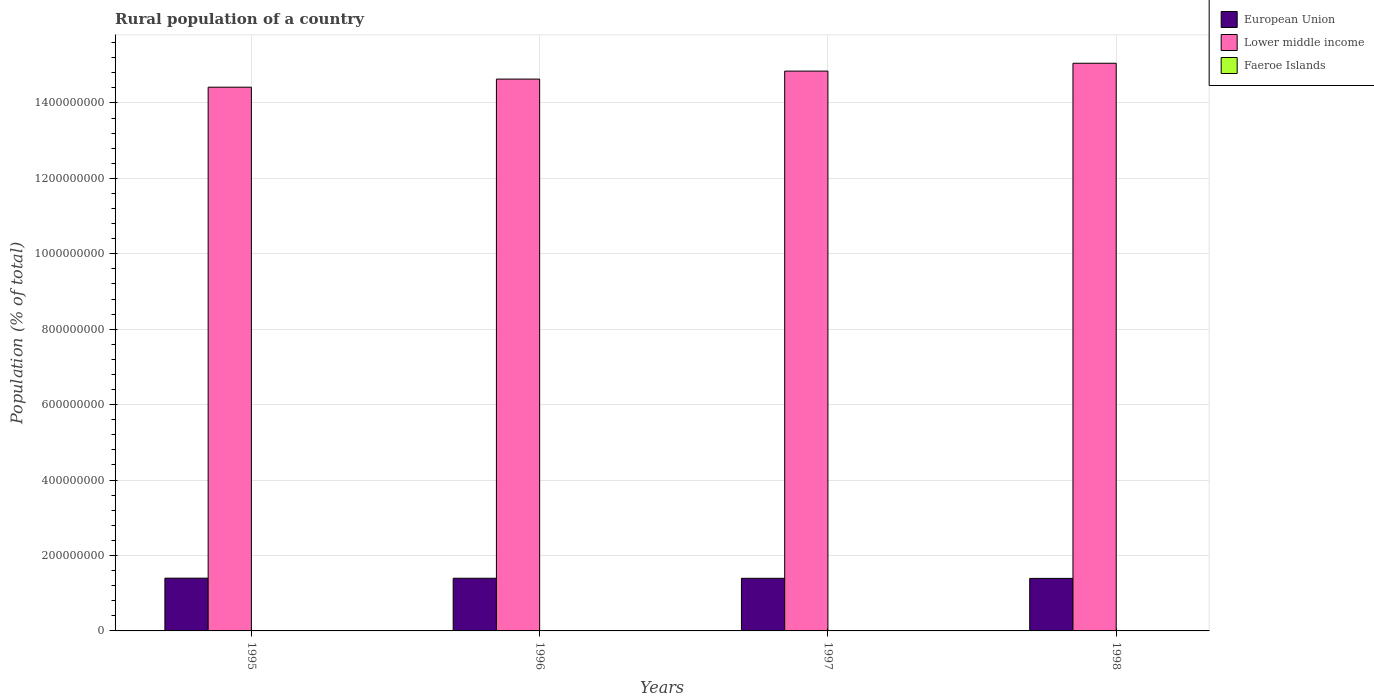How many groups of bars are there?
Make the answer very short. 4. Are the number of bars per tick equal to the number of legend labels?
Ensure brevity in your answer.  Yes. How many bars are there on the 4th tick from the left?
Give a very brief answer. 3. What is the label of the 2nd group of bars from the left?
Ensure brevity in your answer.  1996. What is the rural population in Lower middle income in 1998?
Offer a very short reply. 1.51e+09. Across all years, what is the maximum rural population in European Union?
Offer a terse response. 1.40e+08. Across all years, what is the minimum rural population in Lower middle income?
Your response must be concise. 1.44e+09. What is the total rural population in European Union in the graph?
Your answer should be very brief. 5.58e+08. What is the difference between the rural population in European Union in 1997 and that in 1998?
Ensure brevity in your answer.  2.23e+05. What is the difference between the rural population in European Union in 1997 and the rural population in Faeroe Islands in 1996?
Make the answer very short. 1.39e+08. What is the average rural population in Lower middle income per year?
Make the answer very short. 1.47e+09. In the year 1997, what is the difference between the rural population in Lower middle income and rural population in European Union?
Give a very brief answer. 1.34e+09. What is the ratio of the rural population in Faeroe Islands in 1997 to that in 1998?
Provide a short and direct response. 0.99. Is the rural population in Lower middle income in 1996 less than that in 1997?
Your answer should be compact. Yes. What is the difference between the highest and the second highest rural population in Faeroe Islands?
Provide a short and direct response. 942. What is the difference between the highest and the lowest rural population in Faeroe Islands?
Ensure brevity in your answer.  1715. In how many years, is the rural population in European Union greater than the average rural population in European Union taken over all years?
Your response must be concise. 2. What does the 2nd bar from the left in 1996 represents?
Your answer should be very brief. Lower middle income. What does the 1st bar from the right in 1995 represents?
Make the answer very short. Faeroe Islands. How many bars are there?
Give a very brief answer. 12. Are all the bars in the graph horizontal?
Make the answer very short. No. What is the difference between two consecutive major ticks on the Y-axis?
Ensure brevity in your answer.  2.00e+08. Does the graph contain any zero values?
Provide a succinct answer. No. Does the graph contain grids?
Provide a succinct answer. Yes. How are the legend labels stacked?
Ensure brevity in your answer.  Vertical. What is the title of the graph?
Your response must be concise. Rural population of a country. Does "St. Lucia" appear as one of the legend labels in the graph?
Provide a short and direct response. No. What is the label or title of the Y-axis?
Offer a terse response. Population (% of total). What is the Population (% of total) in European Union in 1995?
Your response must be concise. 1.40e+08. What is the Population (% of total) of Lower middle income in 1995?
Keep it short and to the point. 1.44e+09. What is the Population (% of total) of Faeroe Islands in 1995?
Your answer should be compact. 3.05e+04. What is the Population (% of total) in European Union in 1996?
Give a very brief answer. 1.40e+08. What is the Population (% of total) in Lower middle income in 1996?
Give a very brief answer. 1.46e+09. What is the Population (% of total) in Faeroe Islands in 1996?
Give a very brief answer. 2.95e+04. What is the Population (% of total) of European Union in 1997?
Ensure brevity in your answer.  1.40e+08. What is the Population (% of total) of Lower middle income in 1997?
Your answer should be very brief. 1.48e+09. What is the Population (% of total) in Faeroe Islands in 1997?
Your answer should be very brief. 2.87e+04. What is the Population (% of total) in European Union in 1998?
Provide a succinct answer. 1.39e+08. What is the Population (% of total) in Lower middle income in 1998?
Ensure brevity in your answer.  1.51e+09. What is the Population (% of total) of Faeroe Islands in 1998?
Your answer should be compact. 2.90e+04. Across all years, what is the maximum Population (% of total) in European Union?
Offer a terse response. 1.40e+08. Across all years, what is the maximum Population (% of total) in Lower middle income?
Give a very brief answer. 1.51e+09. Across all years, what is the maximum Population (% of total) of Faeroe Islands?
Provide a succinct answer. 3.05e+04. Across all years, what is the minimum Population (% of total) in European Union?
Keep it short and to the point. 1.39e+08. Across all years, what is the minimum Population (% of total) in Lower middle income?
Your answer should be compact. 1.44e+09. Across all years, what is the minimum Population (% of total) of Faeroe Islands?
Your answer should be compact. 2.87e+04. What is the total Population (% of total) of European Union in the graph?
Ensure brevity in your answer.  5.58e+08. What is the total Population (% of total) in Lower middle income in the graph?
Give a very brief answer. 5.89e+09. What is the total Population (% of total) in Faeroe Islands in the graph?
Your response must be concise. 1.18e+05. What is the difference between the Population (% of total) in European Union in 1995 and that in 1996?
Ensure brevity in your answer.  2.52e+05. What is the difference between the Population (% of total) of Lower middle income in 1995 and that in 1996?
Offer a very short reply. -2.15e+07. What is the difference between the Population (% of total) of Faeroe Islands in 1995 and that in 1996?
Offer a very short reply. 942. What is the difference between the Population (% of total) in European Union in 1995 and that in 1997?
Ensure brevity in your answer.  3.99e+05. What is the difference between the Population (% of total) in Lower middle income in 1995 and that in 1997?
Give a very brief answer. -4.27e+07. What is the difference between the Population (% of total) in Faeroe Islands in 1995 and that in 1997?
Make the answer very short. 1715. What is the difference between the Population (% of total) of European Union in 1995 and that in 1998?
Keep it short and to the point. 6.22e+05. What is the difference between the Population (% of total) in Lower middle income in 1995 and that in 1998?
Make the answer very short. -6.35e+07. What is the difference between the Population (% of total) in Faeroe Islands in 1995 and that in 1998?
Your response must be concise. 1424. What is the difference between the Population (% of total) in European Union in 1996 and that in 1997?
Provide a short and direct response. 1.48e+05. What is the difference between the Population (% of total) in Lower middle income in 1996 and that in 1997?
Offer a very short reply. -2.12e+07. What is the difference between the Population (% of total) of Faeroe Islands in 1996 and that in 1997?
Your answer should be very brief. 773. What is the difference between the Population (% of total) of European Union in 1996 and that in 1998?
Your answer should be very brief. 3.70e+05. What is the difference between the Population (% of total) of Lower middle income in 1996 and that in 1998?
Your answer should be very brief. -4.20e+07. What is the difference between the Population (% of total) of Faeroe Islands in 1996 and that in 1998?
Your response must be concise. 482. What is the difference between the Population (% of total) in European Union in 1997 and that in 1998?
Make the answer very short. 2.23e+05. What is the difference between the Population (% of total) in Lower middle income in 1997 and that in 1998?
Your response must be concise. -2.08e+07. What is the difference between the Population (% of total) of Faeroe Islands in 1997 and that in 1998?
Ensure brevity in your answer.  -291. What is the difference between the Population (% of total) of European Union in 1995 and the Population (% of total) of Lower middle income in 1996?
Your answer should be compact. -1.32e+09. What is the difference between the Population (% of total) of European Union in 1995 and the Population (% of total) of Faeroe Islands in 1996?
Give a very brief answer. 1.40e+08. What is the difference between the Population (% of total) of Lower middle income in 1995 and the Population (% of total) of Faeroe Islands in 1996?
Offer a very short reply. 1.44e+09. What is the difference between the Population (% of total) of European Union in 1995 and the Population (% of total) of Lower middle income in 1997?
Provide a short and direct response. -1.34e+09. What is the difference between the Population (% of total) in European Union in 1995 and the Population (% of total) in Faeroe Islands in 1997?
Your response must be concise. 1.40e+08. What is the difference between the Population (% of total) in Lower middle income in 1995 and the Population (% of total) in Faeroe Islands in 1997?
Provide a succinct answer. 1.44e+09. What is the difference between the Population (% of total) in European Union in 1995 and the Population (% of total) in Lower middle income in 1998?
Keep it short and to the point. -1.37e+09. What is the difference between the Population (% of total) of European Union in 1995 and the Population (% of total) of Faeroe Islands in 1998?
Keep it short and to the point. 1.40e+08. What is the difference between the Population (% of total) in Lower middle income in 1995 and the Population (% of total) in Faeroe Islands in 1998?
Your response must be concise. 1.44e+09. What is the difference between the Population (% of total) in European Union in 1996 and the Population (% of total) in Lower middle income in 1997?
Your answer should be compact. -1.34e+09. What is the difference between the Population (% of total) in European Union in 1996 and the Population (% of total) in Faeroe Islands in 1997?
Offer a terse response. 1.40e+08. What is the difference between the Population (% of total) in Lower middle income in 1996 and the Population (% of total) in Faeroe Islands in 1997?
Provide a succinct answer. 1.46e+09. What is the difference between the Population (% of total) of European Union in 1996 and the Population (% of total) of Lower middle income in 1998?
Your answer should be compact. -1.37e+09. What is the difference between the Population (% of total) of European Union in 1996 and the Population (% of total) of Faeroe Islands in 1998?
Offer a very short reply. 1.40e+08. What is the difference between the Population (% of total) in Lower middle income in 1996 and the Population (% of total) in Faeroe Islands in 1998?
Keep it short and to the point. 1.46e+09. What is the difference between the Population (% of total) of European Union in 1997 and the Population (% of total) of Lower middle income in 1998?
Keep it short and to the point. -1.37e+09. What is the difference between the Population (% of total) in European Union in 1997 and the Population (% of total) in Faeroe Islands in 1998?
Your response must be concise. 1.39e+08. What is the difference between the Population (% of total) of Lower middle income in 1997 and the Population (% of total) of Faeroe Islands in 1998?
Give a very brief answer. 1.48e+09. What is the average Population (% of total) in European Union per year?
Give a very brief answer. 1.40e+08. What is the average Population (% of total) of Lower middle income per year?
Provide a succinct answer. 1.47e+09. What is the average Population (% of total) of Faeroe Islands per year?
Your response must be concise. 2.94e+04. In the year 1995, what is the difference between the Population (% of total) of European Union and Population (% of total) of Lower middle income?
Your answer should be compact. -1.30e+09. In the year 1995, what is the difference between the Population (% of total) in European Union and Population (% of total) in Faeroe Islands?
Your answer should be very brief. 1.40e+08. In the year 1995, what is the difference between the Population (% of total) in Lower middle income and Population (% of total) in Faeroe Islands?
Your answer should be very brief. 1.44e+09. In the year 1996, what is the difference between the Population (% of total) in European Union and Population (% of total) in Lower middle income?
Offer a terse response. -1.32e+09. In the year 1996, what is the difference between the Population (% of total) in European Union and Population (% of total) in Faeroe Islands?
Offer a very short reply. 1.40e+08. In the year 1996, what is the difference between the Population (% of total) of Lower middle income and Population (% of total) of Faeroe Islands?
Make the answer very short. 1.46e+09. In the year 1997, what is the difference between the Population (% of total) in European Union and Population (% of total) in Lower middle income?
Your answer should be compact. -1.34e+09. In the year 1997, what is the difference between the Population (% of total) of European Union and Population (% of total) of Faeroe Islands?
Ensure brevity in your answer.  1.39e+08. In the year 1997, what is the difference between the Population (% of total) in Lower middle income and Population (% of total) in Faeroe Islands?
Provide a succinct answer. 1.48e+09. In the year 1998, what is the difference between the Population (% of total) in European Union and Population (% of total) in Lower middle income?
Provide a succinct answer. -1.37e+09. In the year 1998, what is the difference between the Population (% of total) in European Union and Population (% of total) in Faeroe Islands?
Provide a short and direct response. 1.39e+08. In the year 1998, what is the difference between the Population (% of total) in Lower middle income and Population (% of total) in Faeroe Islands?
Offer a very short reply. 1.51e+09. What is the ratio of the Population (% of total) in Lower middle income in 1995 to that in 1996?
Give a very brief answer. 0.99. What is the ratio of the Population (% of total) of Faeroe Islands in 1995 to that in 1996?
Ensure brevity in your answer.  1.03. What is the ratio of the Population (% of total) in Lower middle income in 1995 to that in 1997?
Make the answer very short. 0.97. What is the ratio of the Population (% of total) of Faeroe Islands in 1995 to that in 1997?
Offer a very short reply. 1.06. What is the ratio of the Population (% of total) of European Union in 1995 to that in 1998?
Provide a succinct answer. 1. What is the ratio of the Population (% of total) of Lower middle income in 1995 to that in 1998?
Offer a very short reply. 0.96. What is the ratio of the Population (% of total) in Faeroe Islands in 1995 to that in 1998?
Give a very brief answer. 1.05. What is the ratio of the Population (% of total) of Lower middle income in 1996 to that in 1997?
Give a very brief answer. 0.99. What is the ratio of the Population (% of total) of Faeroe Islands in 1996 to that in 1997?
Your response must be concise. 1.03. What is the ratio of the Population (% of total) in Lower middle income in 1996 to that in 1998?
Make the answer very short. 0.97. What is the ratio of the Population (% of total) of Faeroe Islands in 1996 to that in 1998?
Offer a terse response. 1.02. What is the ratio of the Population (% of total) in European Union in 1997 to that in 1998?
Keep it short and to the point. 1. What is the ratio of the Population (% of total) in Lower middle income in 1997 to that in 1998?
Give a very brief answer. 0.99. What is the difference between the highest and the second highest Population (% of total) in European Union?
Give a very brief answer. 2.52e+05. What is the difference between the highest and the second highest Population (% of total) of Lower middle income?
Your answer should be compact. 2.08e+07. What is the difference between the highest and the second highest Population (% of total) in Faeroe Islands?
Your answer should be compact. 942. What is the difference between the highest and the lowest Population (% of total) of European Union?
Provide a short and direct response. 6.22e+05. What is the difference between the highest and the lowest Population (% of total) in Lower middle income?
Ensure brevity in your answer.  6.35e+07. What is the difference between the highest and the lowest Population (% of total) in Faeroe Islands?
Ensure brevity in your answer.  1715. 